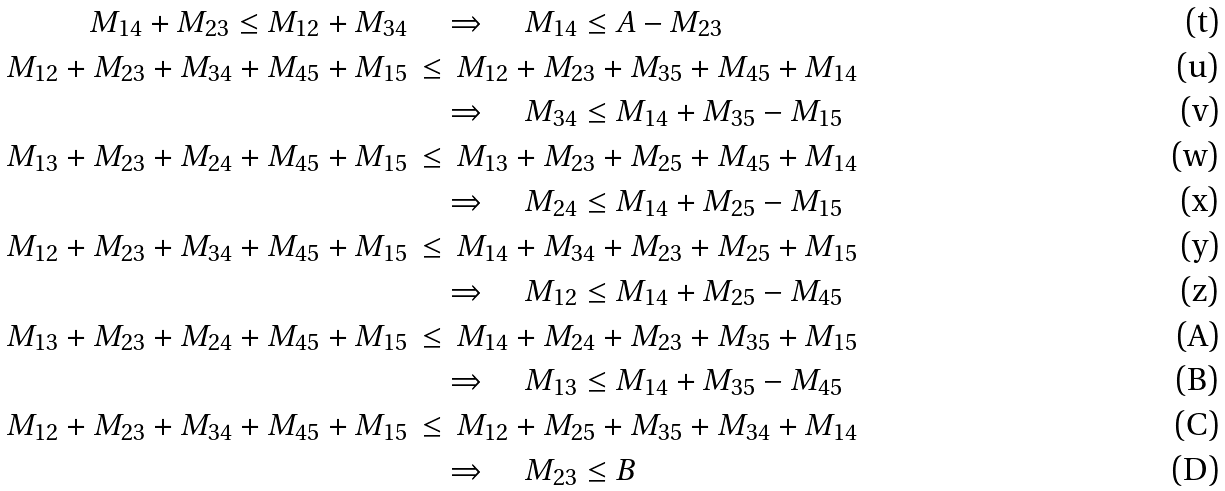Convert formula to latex. <formula><loc_0><loc_0><loc_500><loc_500>M _ { 1 4 } + M _ { 2 3 } \leq M _ { 1 2 } + M _ { 3 4 } & \quad \Rightarrow \quad M _ { 1 4 } \leq A - M _ { 2 3 } \\ M _ { 1 2 } + M _ { 2 3 } + M _ { 3 4 } + M _ { 4 5 } + M _ { 1 5 } & \, \leq \, M _ { 1 2 } + M _ { 2 3 } + M _ { 3 5 } + M _ { 4 5 } + M _ { 1 4 } \\ & \quad \Rightarrow \quad M _ { 3 4 } \leq M _ { 1 4 } + M _ { 3 5 } - M _ { 1 5 } \\ M _ { 1 3 } + M _ { 2 3 } + M _ { 2 4 } + M _ { 4 5 } + M _ { 1 5 } & \, \leq \, M _ { 1 3 } + M _ { 2 3 } + M _ { 2 5 } + M _ { 4 5 } + M _ { 1 4 } \\ & \quad \Rightarrow \quad M _ { 2 4 } \leq M _ { 1 4 } + M _ { 2 5 } - M _ { 1 5 } \\ M _ { 1 2 } + M _ { 2 3 } + M _ { 3 4 } + M _ { 4 5 } + M _ { 1 5 } & \, \leq \, M _ { 1 4 } + M _ { 3 4 } + M _ { 2 3 } + M _ { 2 5 } + M _ { 1 5 } \\ & \quad \Rightarrow \quad M _ { 1 2 } \leq M _ { 1 4 } + M _ { 2 5 } - M _ { 4 5 } \\ M _ { 1 3 } + M _ { 2 3 } + M _ { 2 4 } + M _ { 4 5 } + M _ { 1 5 } & \, \leq \, M _ { 1 4 } + M _ { 2 4 } + M _ { 2 3 } + M _ { 3 5 } + M _ { 1 5 } \\ & \quad \Rightarrow \quad M _ { 1 3 } \leq M _ { 1 4 } + M _ { 3 5 } - M _ { 4 5 } \\ M _ { 1 2 } + M _ { 2 3 } + M _ { 3 4 } + M _ { 4 5 } + M _ { 1 5 } & \, \leq \, M _ { 1 2 } + M _ { 2 5 } + M _ { 3 5 } + M _ { 3 4 } + M _ { 1 4 } \\ & \quad \Rightarrow \quad M _ { 2 3 } \leq B</formula> 